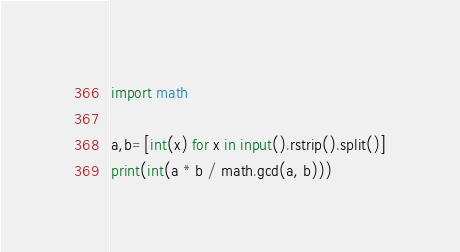<code> <loc_0><loc_0><loc_500><loc_500><_Python_>import math

a,b=[int(x) for x in input().rstrip().split()]
print(int(a * b / math.gcd(a, b)))</code> 